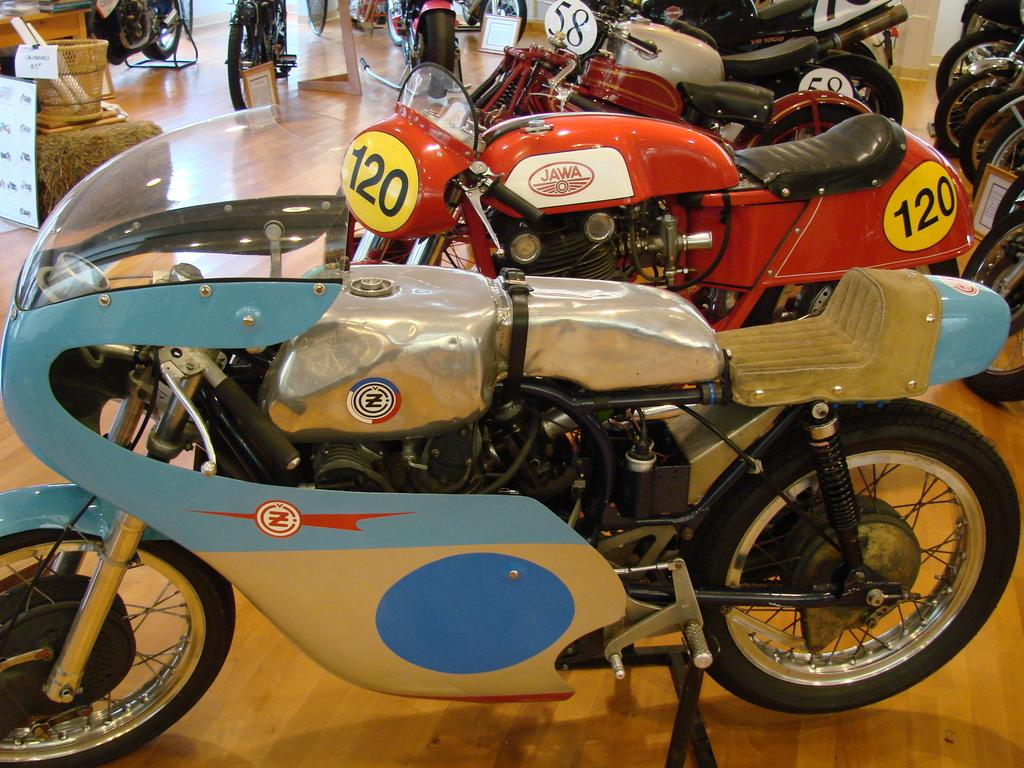What types of vehicles are featured in the image? There are different models of motorcycles in the image. How are the motorcycles presented in the image? The motorcycles are displayed. What can be found in a basket at the corner of the image? There are two paper rolls in a basket at the corner of the image. What is the purpose of the placard in the image? The purpose of the placard in the image is not specified, but it may provide information about the motorcycles. What piece of furniture is present in the image? There is a table in the image. Can you see a giraffe using a wrench to fix a motorcycle in the image? No, there is no giraffe or wrench present in the image, and motorcycles are displayed, not being fixed. 